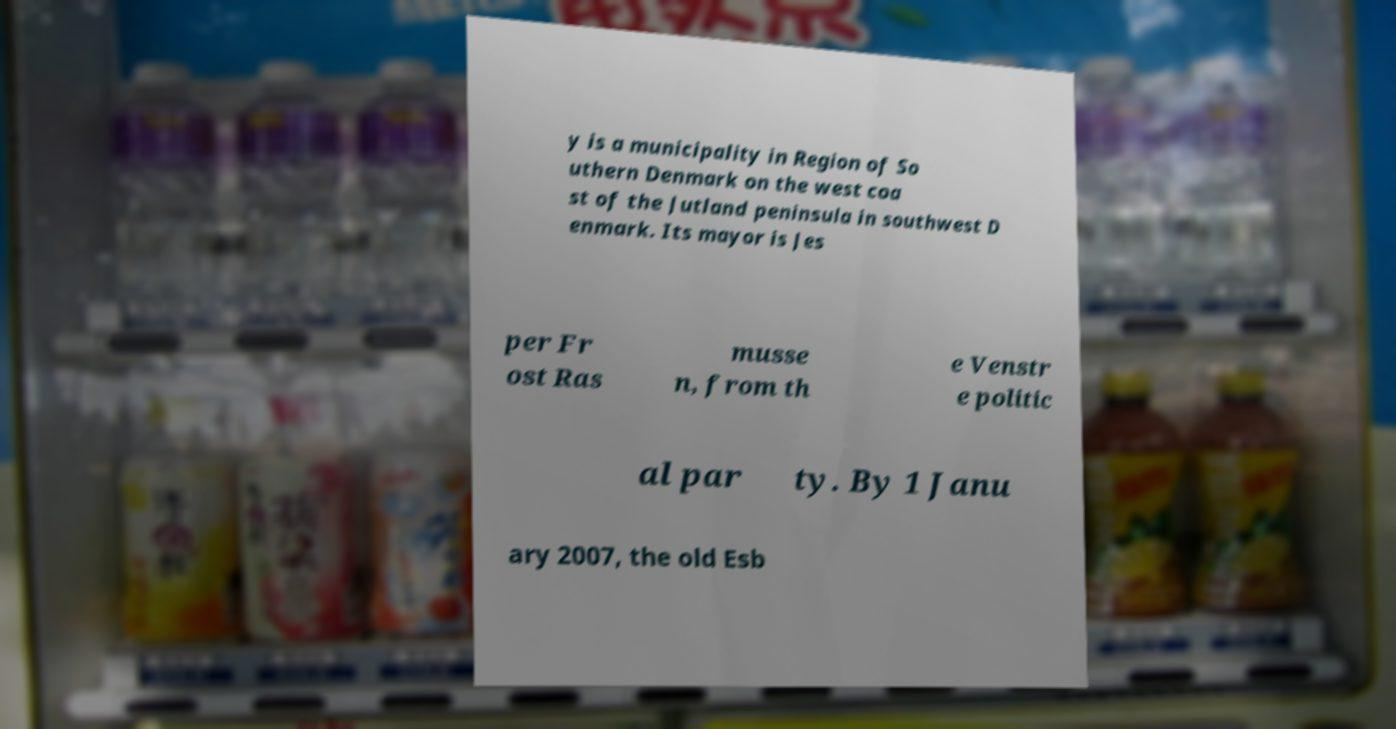What messages or text are displayed in this image? I need them in a readable, typed format. y is a municipality in Region of So uthern Denmark on the west coa st of the Jutland peninsula in southwest D enmark. Its mayor is Jes per Fr ost Ras musse n, from th e Venstr e politic al par ty. By 1 Janu ary 2007, the old Esb 